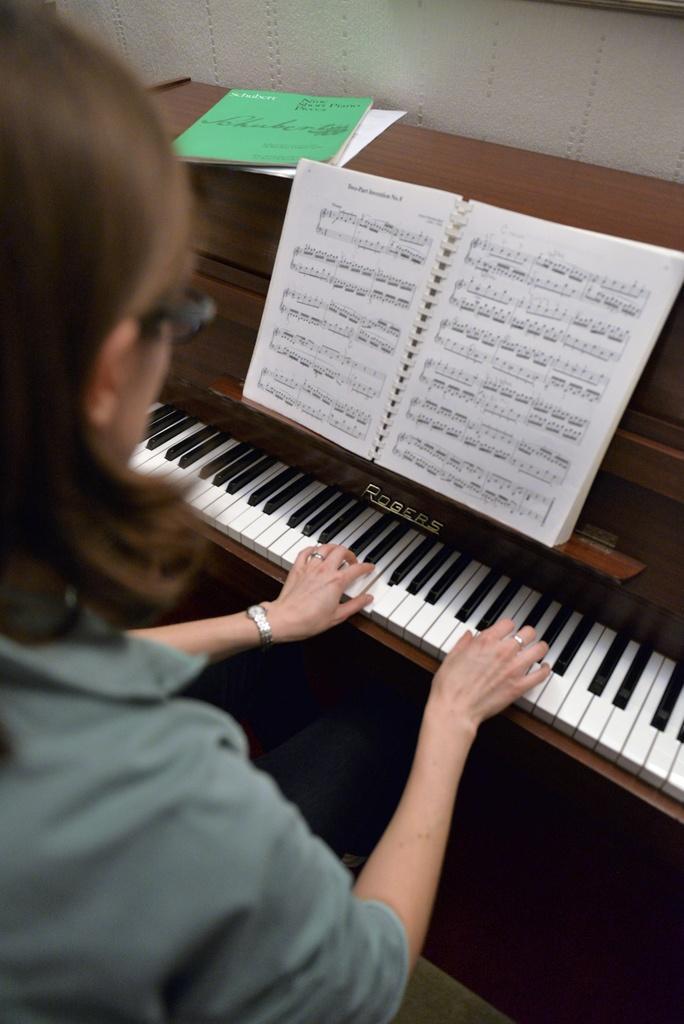In one or two sentences, can you explain what this image depicts? This image consists of a woman and a keyboard. She is playing the keyboard. There is also a book placed on the keyboard. 